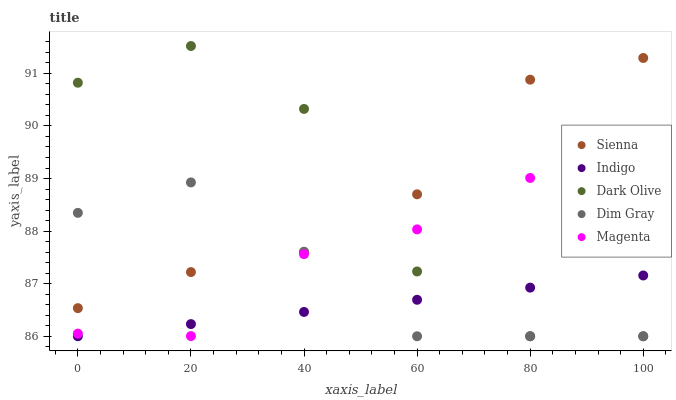Does Indigo have the minimum area under the curve?
Answer yes or no. Yes. Does Dark Olive have the maximum area under the curve?
Answer yes or no. Yes. Does Dim Gray have the minimum area under the curve?
Answer yes or no. No. Does Dim Gray have the maximum area under the curve?
Answer yes or no. No. Is Indigo the smoothest?
Answer yes or no. Yes. Is Dark Olive the roughest?
Answer yes or no. Yes. Is Dim Gray the smoothest?
Answer yes or no. No. Is Dim Gray the roughest?
Answer yes or no. No. Does Dim Gray have the lowest value?
Answer yes or no. Yes. Does Magenta have the lowest value?
Answer yes or no. No. Does Dark Olive have the highest value?
Answer yes or no. Yes. Does Dim Gray have the highest value?
Answer yes or no. No. Is Indigo less than Sienna?
Answer yes or no. Yes. Is Sienna greater than Indigo?
Answer yes or no. Yes. Does Dark Olive intersect Dim Gray?
Answer yes or no. Yes. Is Dark Olive less than Dim Gray?
Answer yes or no. No. Is Dark Olive greater than Dim Gray?
Answer yes or no. No. Does Indigo intersect Sienna?
Answer yes or no. No. 